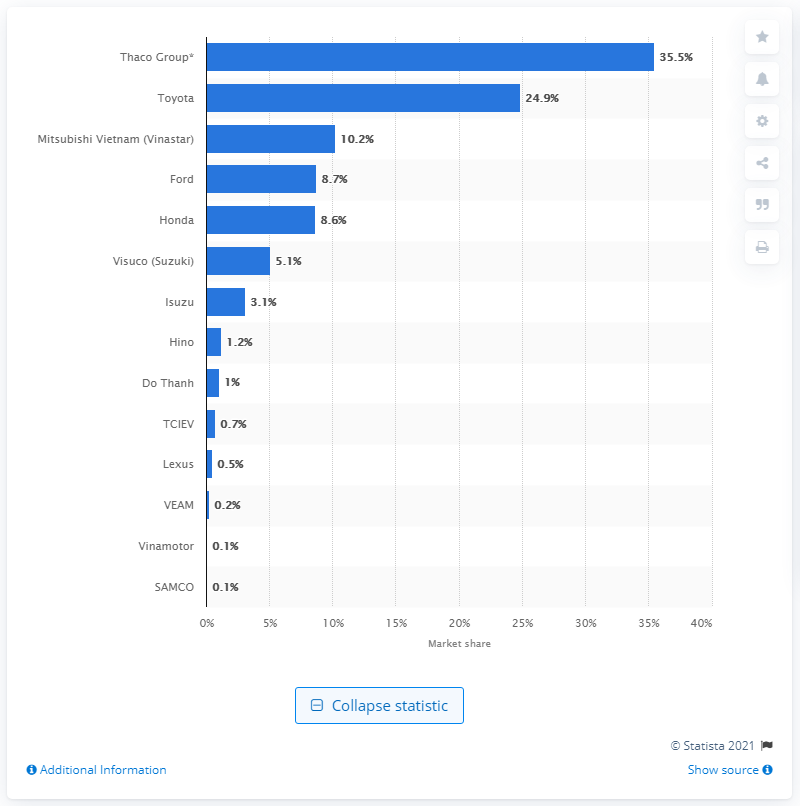Point out several critical features in this image. In 2020, Thaco Group held a market share of 35.5% of its market. 